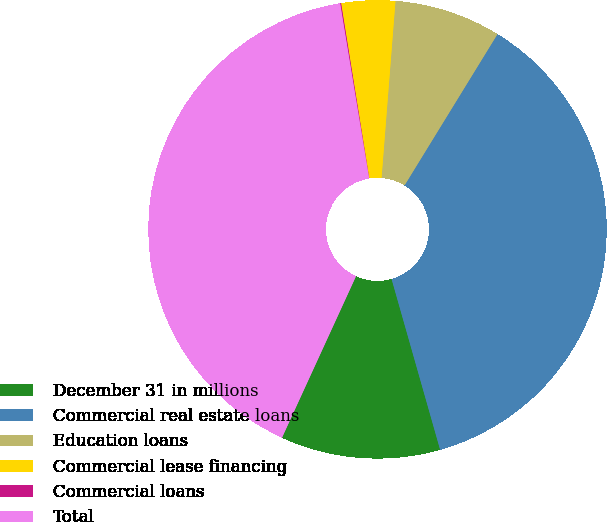Convert chart to OTSL. <chart><loc_0><loc_0><loc_500><loc_500><pie_chart><fcel>December 31 in millions<fcel>Commercial real estate loans<fcel>Education loans<fcel>Commercial lease financing<fcel>Commercial loans<fcel>Total<nl><fcel>11.25%<fcel>36.82%<fcel>7.52%<fcel>3.79%<fcel>0.07%<fcel>40.55%<nl></chart> 